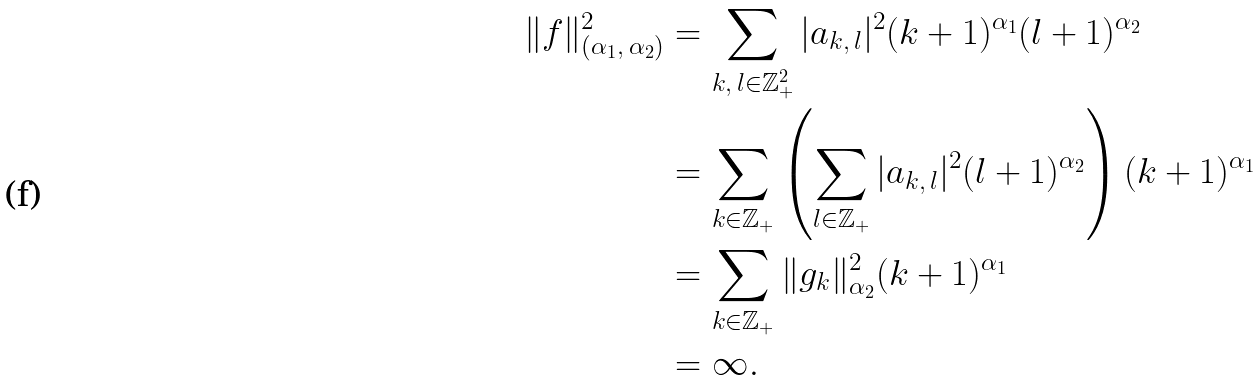Convert formula to latex. <formula><loc_0><loc_0><loc_500><loc_500>\| f \| ^ { 2 } _ { ( \alpha _ { 1 } , \, \alpha _ { 2 } ) } & = \sum _ { k , \, l \in \mathbb { Z } ^ { 2 } _ { + } } | a _ { k , \, l } | ^ { 2 } ( k + 1 ) ^ { \alpha _ { 1 } } ( l + 1 ) ^ { \alpha _ { 2 } } \\ & = \sum _ { k \in \mathbb { Z } _ { + } } \left ( \sum _ { l \in \mathbb { Z } _ { + } } | a _ { k , \, l } | ^ { 2 } ( l + 1 ) ^ { \alpha _ { 2 } } \right ) ( k + 1 ) ^ { \alpha _ { 1 } } \\ & = \sum _ { k \in \mathbb { Z } _ { + } } \| g _ { k } \| ^ { 2 } _ { \alpha _ { 2 } } ( k + 1 ) ^ { \alpha _ { 1 } } \\ & = \infty .</formula> 